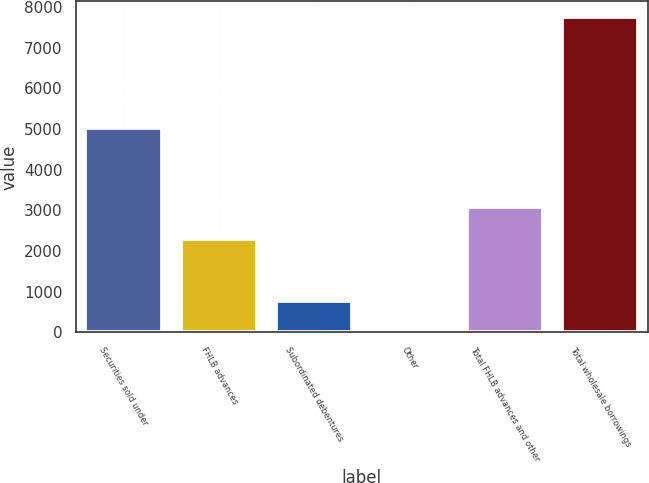<chart> <loc_0><loc_0><loc_500><loc_500><bar_chart><fcel>Securities sold under<fcel>FHLB advances<fcel>Subordinated debentures<fcel>Other<fcel>Total FHLB advances and other<fcel>Total wholesale borrowings<nl><fcel>5015.5<fcel>2302.7<fcel>781.18<fcel>6.6<fcel>3077.28<fcel>7752.4<nl></chart> 